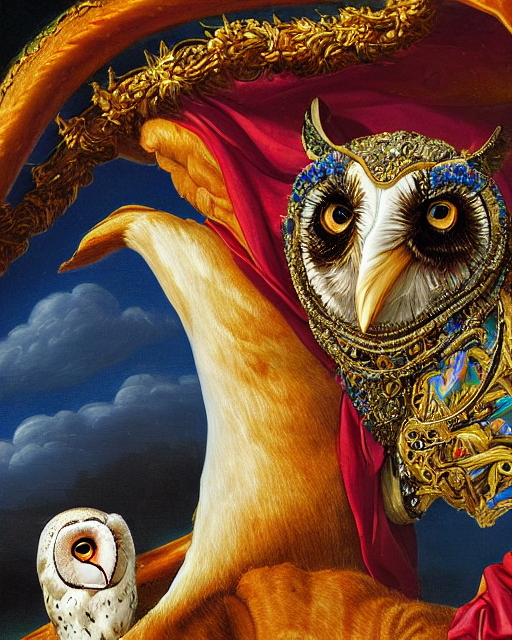What emotions does the imagery evoke, and what might the artist be trying to convey? The imagery evokes a sense of intrigue and majesty, with the noble posture of the owl suggesting wisdom and regality. The juxtaposition of a creature of the night adorned with such luxurious ornamentation could convey the idea of hidden beauty or the uncovering of profound truths under the veil of darkness. 